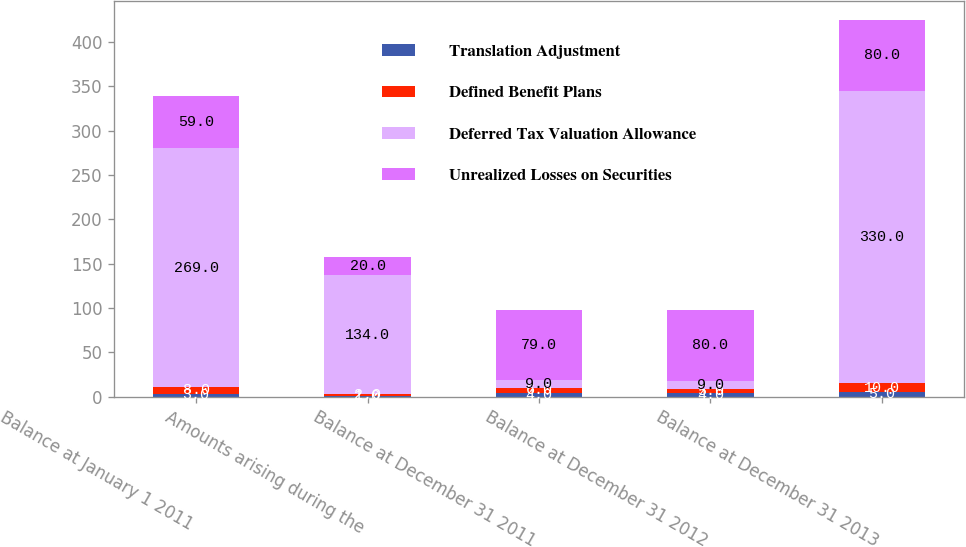Convert chart to OTSL. <chart><loc_0><loc_0><loc_500><loc_500><stacked_bar_chart><ecel><fcel>Balance at January 1 2011<fcel>Amounts arising during the<fcel>Balance at December 31 2011<fcel>Balance at December 31 2012<fcel>Balance at December 31 2013<nl><fcel>Translation Adjustment<fcel>3<fcel>1<fcel>4<fcel>4<fcel>5<nl><fcel>Defined Benefit Plans<fcel>8<fcel>2<fcel>6<fcel>5<fcel>10<nl><fcel>Deferred Tax Valuation Allowance<fcel>269<fcel>134<fcel>9<fcel>9<fcel>330<nl><fcel>Unrealized Losses on Securities<fcel>59<fcel>20<fcel>79<fcel>80<fcel>80<nl></chart> 